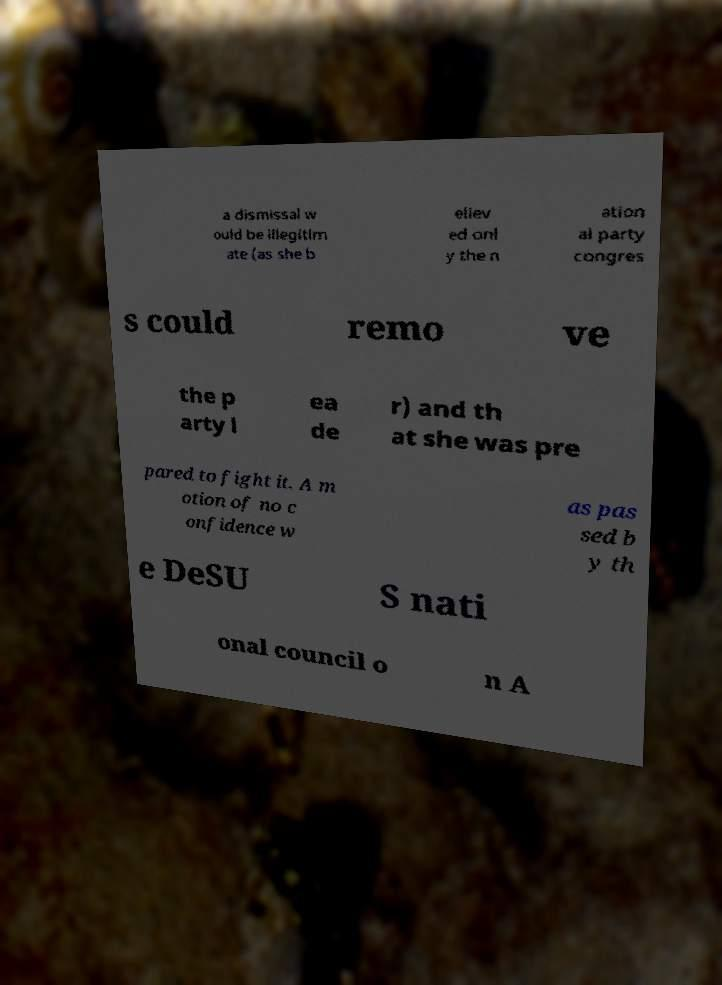Can you read and provide the text displayed in the image?This photo seems to have some interesting text. Can you extract and type it out for me? a dismissal w ould be illegitim ate (as she b eliev ed onl y the n ation al party congres s could remo ve the p arty l ea de r) and th at she was pre pared to fight it. A m otion of no c onfidence w as pas sed b y th e DeSU S nati onal council o n A 